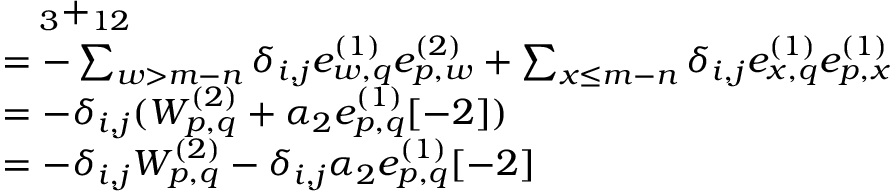<formula> <loc_0><loc_0><loc_500><loc_500>\begin{array} { r l } & { \quad _ { 3 } + _ { 1 2 } } \\ & { = - \sum _ { w > m - n } \delta _ { i , j } e _ { w , q } ^ { ( 1 ) } e _ { p , w } ^ { ( 2 ) } + \sum _ { x \leq m - n } \delta _ { i , j } e _ { x , q } ^ { ( 1 ) } e _ { p , x } ^ { ( 1 ) } } \\ & { = - \delta _ { i , j } ( W _ { p , q } ^ { ( 2 ) } + \alpha _ { 2 } e _ { p , q } ^ { ( 1 ) } [ - 2 ] ) } \\ & { = - \delta _ { i , j } W _ { p , q } ^ { ( 2 ) } - \delta _ { i , j } \alpha _ { 2 } e _ { p , q } ^ { ( 1 ) } [ - 2 ] } \end{array}</formula> 